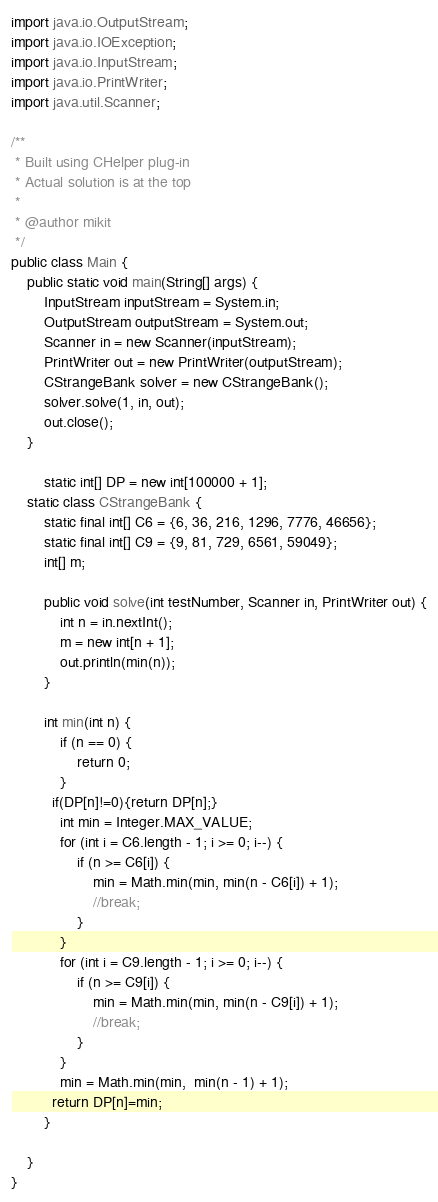Convert code to text. <code><loc_0><loc_0><loc_500><loc_500><_Java_>import java.io.OutputStream;
import java.io.IOException;
import java.io.InputStream;
import java.io.PrintWriter;
import java.util.Scanner;

/**
 * Built using CHelper plug-in
 * Actual solution is at the top
 *
 * @author mikit
 */
public class Main {
    public static void main(String[] args) {
        InputStream inputStream = System.in;
        OutputStream outputStream = System.out;
        Scanner in = new Scanner(inputStream);
        PrintWriter out = new PrintWriter(outputStream);
        CStrangeBank solver = new CStrangeBank();
        solver.solve(1, in, out);
        out.close();
    }

        static int[] DP = new int[100000 + 1];
    static class CStrangeBank {
        static final int[] C6 = {6, 36, 216, 1296, 7776, 46656};
        static final int[] C9 = {9, 81, 729, 6561, 59049};
        int[] m;

        public void solve(int testNumber, Scanner in, PrintWriter out) {
            int n = in.nextInt();
            m = new int[n + 1];
            out.println(min(n));
        }

        int min(int n) {
            if (n == 0) {
                return 0;
            }
          if(DP[n]!=0){return DP[n];}
            int min = Integer.MAX_VALUE;
            for (int i = C6.length - 1; i >= 0; i--) {
                if (n >= C6[i]) {
                    min = Math.min(min, min(n - C6[i]) + 1);
                    //break;
                }
            }
            for (int i = C9.length - 1; i >= 0; i--) {
                if (n >= C9[i]) {
                    min = Math.min(min, min(n - C9[i]) + 1);
                    //break;
                }
            }
            min = Math.min(min,  min(n - 1) + 1);
          return DP[n]=min;
        }

    }
}

</code> 